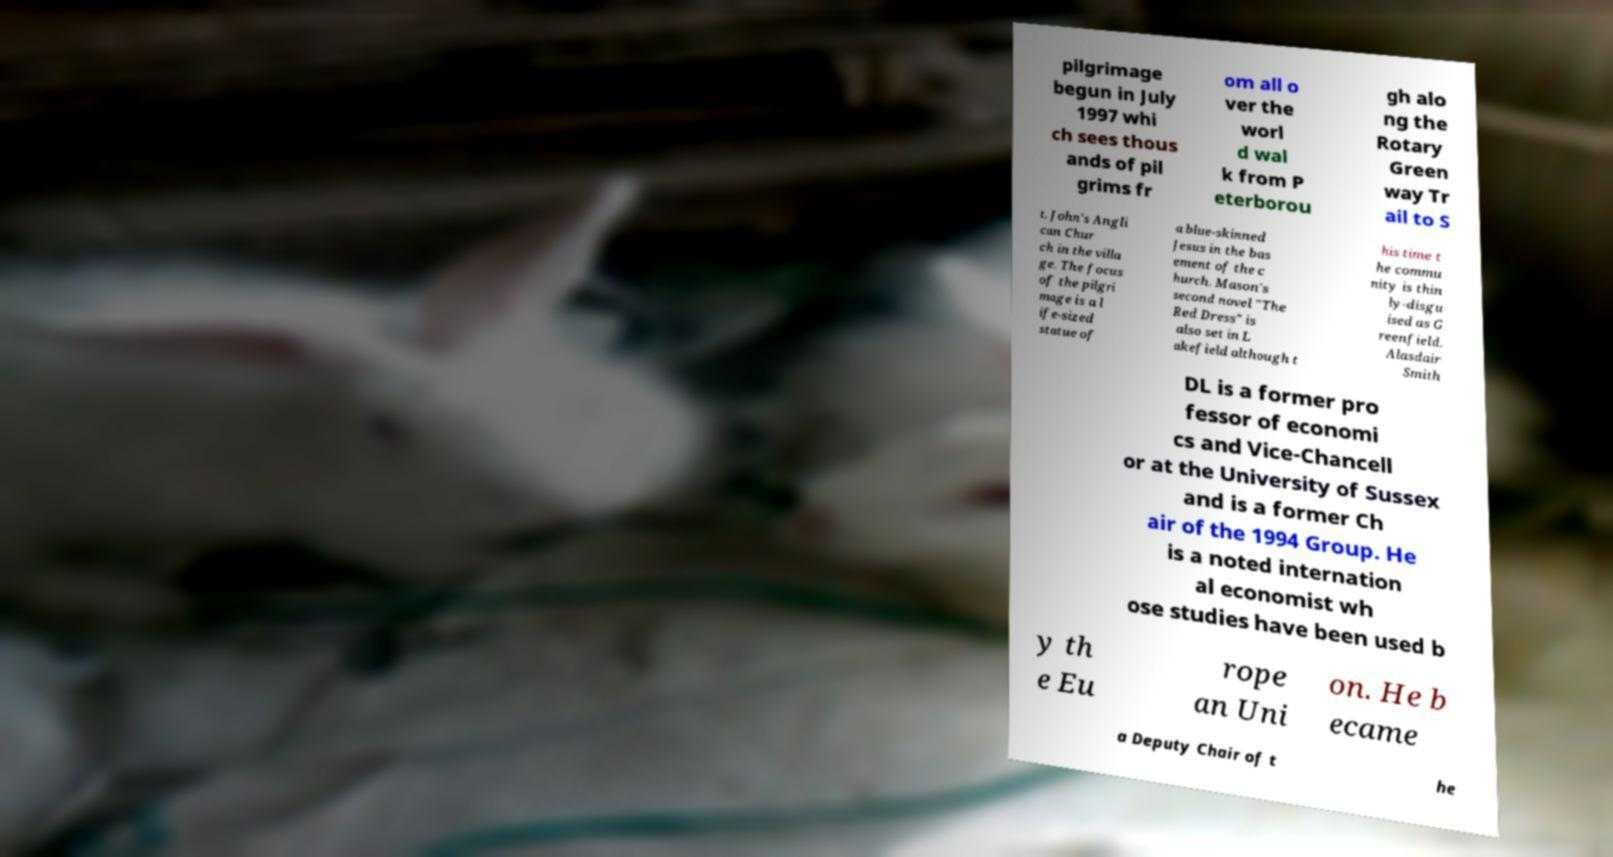What messages or text are displayed in this image? I need them in a readable, typed format. pilgrimage begun in July 1997 whi ch sees thous ands of pil grims fr om all o ver the worl d wal k from P eterborou gh alo ng the Rotary Green way Tr ail to S t. John's Angli can Chur ch in the villa ge. The focus of the pilgri mage is a l ife-sized statue of a blue-skinned Jesus in the bas ement of the c hurch. Mason's second novel "The Red Dress" is also set in L akefield although t his time t he commu nity is thin ly-disgu ised as G reenfield. Alasdair Smith DL is a former pro fessor of economi cs and Vice-Chancell or at the University of Sussex and is a former Ch air of the 1994 Group. He is a noted internation al economist wh ose studies have been used b y th e Eu rope an Uni on. He b ecame a Deputy Chair of t he 